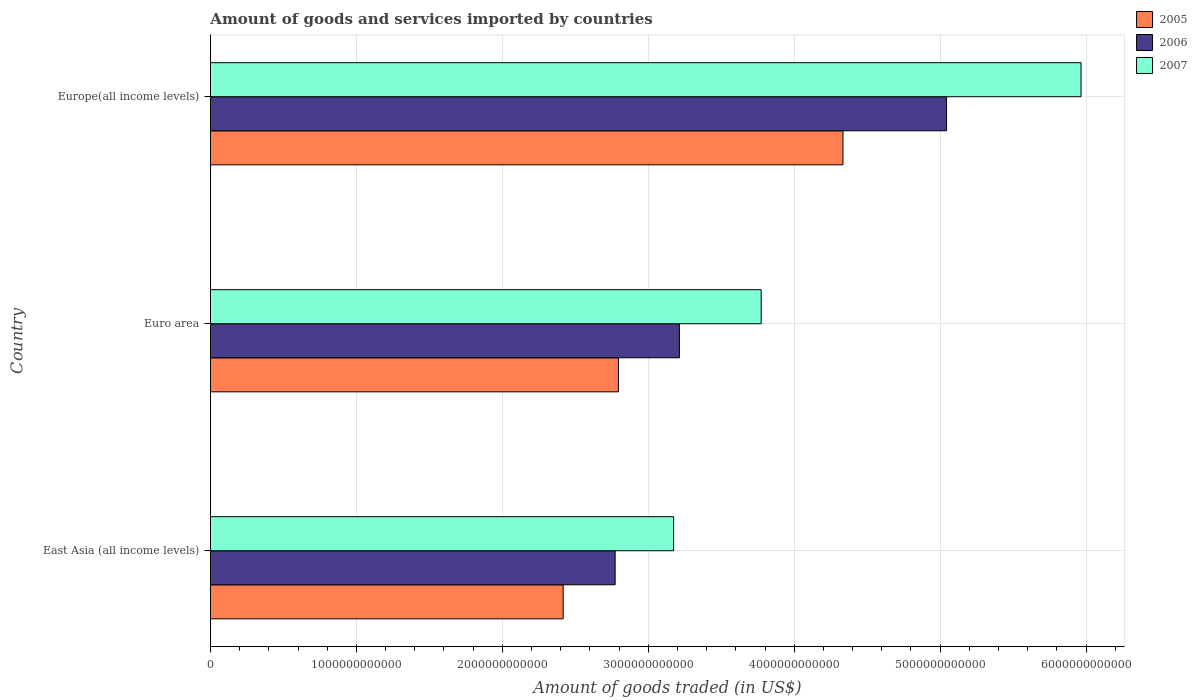How many groups of bars are there?
Make the answer very short. 3. Are the number of bars per tick equal to the number of legend labels?
Keep it short and to the point. Yes. Are the number of bars on each tick of the Y-axis equal?
Make the answer very short. Yes. How many bars are there on the 2nd tick from the top?
Provide a succinct answer. 3. What is the total amount of goods and services imported in 2006 in Euro area?
Ensure brevity in your answer.  3.21e+12. Across all countries, what is the maximum total amount of goods and services imported in 2006?
Give a very brief answer. 5.04e+12. Across all countries, what is the minimum total amount of goods and services imported in 2005?
Give a very brief answer. 2.42e+12. In which country was the total amount of goods and services imported in 2005 maximum?
Provide a succinct answer. Europe(all income levels). In which country was the total amount of goods and services imported in 2005 minimum?
Provide a short and direct response. East Asia (all income levels). What is the total total amount of goods and services imported in 2007 in the graph?
Ensure brevity in your answer.  1.29e+13. What is the difference between the total amount of goods and services imported in 2006 in East Asia (all income levels) and that in Euro area?
Offer a terse response. -4.40e+11. What is the difference between the total amount of goods and services imported in 2006 in Euro area and the total amount of goods and services imported in 2007 in East Asia (all income levels)?
Give a very brief answer. 3.96e+1. What is the average total amount of goods and services imported in 2005 per country?
Make the answer very short. 3.18e+12. What is the difference between the total amount of goods and services imported in 2005 and total amount of goods and services imported in 2007 in Euro area?
Your answer should be very brief. -9.78e+11. What is the ratio of the total amount of goods and services imported in 2007 in East Asia (all income levels) to that in Europe(all income levels)?
Your answer should be very brief. 0.53. Is the total amount of goods and services imported in 2007 in Euro area less than that in Europe(all income levels)?
Offer a terse response. Yes. What is the difference between the highest and the second highest total amount of goods and services imported in 2005?
Give a very brief answer. 1.54e+12. What is the difference between the highest and the lowest total amount of goods and services imported in 2007?
Provide a succinct answer. 2.79e+12. Is the sum of the total amount of goods and services imported in 2005 in East Asia (all income levels) and Euro area greater than the maximum total amount of goods and services imported in 2006 across all countries?
Offer a terse response. Yes. What does the 2nd bar from the top in East Asia (all income levels) represents?
Make the answer very short. 2006. What does the 1st bar from the bottom in Europe(all income levels) represents?
Your answer should be very brief. 2005. Is it the case that in every country, the sum of the total amount of goods and services imported in 2006 and total amount of goods and services imported in 2007 is greater than the total amount of goods and services imported in 2005?
Ensure brevity in your answer.  Yes. How many bars are there?
Offer a very short reply. 9. Are all the bars in the graph horizontal?
Make the answer very short. Yes. How many countries are there in the graph?
Ensure brevity in your answer.  3. What is the difference between two consecutive major ticks on the X-axis?
Make the answer very short. 1.00e+12. Where does the legend appear in the graph?
Your answer should be compact. Top right. What is the title of the graph?
Ensure brevity in your answer.  Amount of goods and services imported by countries. Does "1974" appear as one of the legend labels in the graph?
Provide a succinct answer. No. What is the label or title of the X-axis?
Your answer should be very brief. Amount of goods traded (in US$). What is the Amount of goods traded (in US$) of 2005 in East Asia (all income levels)?
Your response must be concise. 2.42e+12. What is the Amount of goods traded (in US$) of 2006 in East Asia (all income levels)?
Your response must be concise. 2.77e+12. What is the Amount of goods traded (in US$) in 2007 in East Asia (all income levels)?
Make the answer very short. 3.17e+12. What is the Amount of goods traded (in US$) in 2005 in Euro area?
Provide a short and direct response. 2.80e+12. What is the Amount of goods traded (in US$) of 2006 in Euro area?
Provide a short and direct response. 3.21e+12. What is the Amount of goods traded (in US$) in 2007 in Euro area?
Give a very brief answer. 3.77e+12. What is the Amount of goods traded (in US$) of 2005 in Europe(all income levels)?
Keep it short and to the point. 4.33e+12. What is the Amount of goods traded (in US$) in 2006 in Europe(all income levels)?
Ensure brevity in your answer.  5.04e+12. What is the Amount of goods traded (in US$) of 2007 in Europe(all income levels)?
Keep it short and to the point. 5.97e+12. Across all countries, what is the maximum Amount of goods traded (in US$) of 2005?
Offer a very short reply. 4.33e+12. Across all countries, what is the maximum Amount of goods traded (in US$) in 2006?
Offer a terse response. 5.04e+12. Across all countries, what is the maximum Amount of goods traded (in US$) in 2007?
Your answer should be compact. 5.97e+12. Across all countries, what is the minimum Amount of goods traded (in US$) of 2005?
Offer a terse response. 2.42e+12. Across all countries, what is the minimum Amount of goods traded (in US$) of 2006?
Your answer should be very brief. 2.77e+12. Across all countries, what is the minimum Amount of goods traded (in US$) in 2007?
Your response must be concise. 3.17e+12. What is the total Amount of goods traded (in US$) in 2005 in the graph?
Make the answer very short. 9.55e+12. What is the total Amount of goods traded (in US$) in 2006 in the graph?
Your answer should be very brief. 1.10e+13. What is the total Amount of goods traded (in US$) in 2007 in the graph?
Keep it short and to the point. 1.29e+13. What is the difference between the Amount of goods traded (in US$) in 2005 in East Asia (all income levels) and that in Euro area?
Offer a terse response. -3.79e+11. What is the difference between the Amount of goods traded (in US$) in 2006 in East Asia (all income levels) and that in Euro area?
Keep it short and to the point. -4.40e+11. What is the difference between the Amount of goods traded (in US$) of 2007 in East Asia (all income levels) and that in Euro area?
Your answer should be compact. -6.00e+11. What is the difference between the Amount of goods traded (in US$) of 2005 in East Asia (all income levels) and that in Europe(all income levels)?
Offer a very short reply. -1.92e+12. What is the difference between the Amount of goods traded (in US$) of 2006 in East Asia (all income levels) and that in Europe(all income levels)?
Keep it short and to the point. -2.27e+12. What is the difference between the Amount of goods traded (in US$) of 2007 in East Asia (all income levels) and that in Europe(all income levels)?
Ensure brevity in your answer.  -2.79e+12. What is the difference between the Amount of goods traded (in US$) in 2005 in Euro area and that in Europe(all income levels)?
Keep it short and to the point. -1.54e+12. What is the difference between the Amount of goods traded (in US$) of 2006 in Euro area and that in Europe(all income levels)?
Your answer should be compact. -1.83e+12. What is the difference between the Amount of goods traded (in US$) in 2007 in Euro area and that in Europe(all income levels)?
Your answer should be very brief. -2.19e+12. What is the difference between the Amount of goods traded (in US$) of 2005 in East Asia (all income levels) and the Amount of goods traded (in US$) of 2006 in Euro area?
Keep it short and to the point. -7.96e+11. What is the difference between the Amount of goods traded (in US$) in 2005 in East Asia (all income levels) and the Amount of goods traded (in US$) in 2007 in Euro area?
Ensure brevity in your answer.  -1.36e+12. What is the difference between the Amount of goods traded (in US$) of 2006 in East Asia (all income levels) and the Amount of goods traded (in US$) of 2007 in Euro area?
Offer a very short reply. -1.00e+12. What is the difference between the Amount of goods traded (in US$) in 2005 in East Asia (all income levels) and the Amount of goods traded (in US$) in 2006 in Europe(all income levels)?
Keep it short and to the point. -2.63e+12. What is the difference between the Amount of goods traded (in US$) of 2005 in East Asia (all income levels) and the Amount of goods traded (in US$) of 2007 in Europe(all income levels)?
Give a very brief answer. -3.55e+12. What is the difference between the Amount of goods traded (in US$) in 2006 in East Asia (all income levels) and the Amount of goods traded (in US$) in 2007 in Europe(all income levels)?
Provide a short and direct response. -3.19e+12. What is the difference between the Amount of goods traded (in US$) in 2005 in Euro area and the Amount of goods traded (in US$) in 2006 in Europe(all income levels)?
Offer a terse response. -2.25e+12. What is the difference between the Amount of goods traded (in US$) of 2005 in Euro area and the Amount of goods traded (in US$) of 2007 in Europe(all income levels)?
Provide a short and direct response. -3.17e+12. What is the difference between the Amount of goods traded (in US$) of 2006 in Euro area and the Amount of goods traded (in US$) of 2007 in Europe(all income levels)?
Provide a succinct answer. -2.75e+12. What is the average Amount of goods traded (in US$) in 2005 per country?
Your answer should be very brief. 3.18e+12. What is the average Amount of goods traded (in US$) in 2006 per country?
Ensure brevity in your answer.  3.68e+12. What is the average Amount of goods traded (in US$) of 2007 per country?
Offer a terse response. 4.30e+12. What is the difference between the Amount of goods traded (in US$) in 2005 and Amount of goods traded (in US$) in 2006 in East Asia (all income levels)?
Provide a short and direct response. -3.56e+11. What is the difference between the Amount of goods traded (in US$) in 2005 and Amount of goods traded (in US$) in 2007 in East Asia (all income levels)?
Give a very brief answer. -7.57e+11. What is the difference between the Amount of goods traded (in US$) in 2006 and Amount of goods traded (in US$) in 2007 in East Asia (all income levels)?
Offer a terse response. -4.01e+11. What is the difference between the Amount of goods traded (in US$) of 2005 and Amount of goods traded (in US$) of 2006 in Euro area?
Offer a very short reply. -4.18e+11. What is the difference between the Amount of goods traded (in US$) in 2005 and Amount of goods traded (in US$) in 2007 in Euro area?
Ensure brevity in your answer.  -9.78e+11. What is the difference between the Amount of goods traded (in US$) of 2006 and Amount of goods traded (in US$) of 2007 in Euro area?
Provide a succinct answer. -5.60e+11. What is the difference between the Amount of goods traded (in US$) in 2005 and Amount of goods traded (in US$) in 2006 in Europe(all income levels)?
Keep it short and to the point. -7.10e+11. What is the difference between the Amount of goods traded (in US$) in 2005 and Amount of goods traded (in US$) in 2007 in Europe(all income levels)?
Your answer should be compact. -1.63e+12. What is the difference between the Amount of goods traded (in US$) of 2006 and Amount of goods traded (in US$) of 2007 in Europe(all income levels)?
Ensure brevity in your answer.  -9.22e+11. What is the ratio of the Amount of goods traded (in US$) of 2005 in East Asia (all income levels) to that in Euro area?
Offer a very short reply. 0.86. What is the ratio of the Amount of goods traded (in US$) of 2006 in East Asia (all income levels) to that in Euro area?
Your answer should be compact. 0.86. What is the ratio of the Amount of goods traded (in US$) in 2007 in East Asia (all income levels) to that in Euro area?
Give a very brief answer. 0.84. What is the ratio of the Amount of goods traded (in US$) in 2005 in East Asia (all income levels) to that in Europe(all income levels)?
Offer a terse response. 0.56. What is the ratio of the Amount of goods traded (in US$) of 2006 in East Asia (all income levels) to that in Europe(all income levels)?
Provide a short and direct response. 0.55. What is the ratio of the Amount of goods traded (in US$) of 2007 in East Asia (all income levels) to that in Europe(all income levels)?
Give a very brief answer. 0.53. What is the ratio of the Amount of goods traded (in US$) in 2005 in Euro area to that in Europe(all income levels)?
Provide a succinct answer. 0.65. What is the ratio of the Amount of goods traded (in US$) in 2006 in Euro area to that in Europe(all income levels)?
Offer a terse response. 0.64. What is the ratio of the Amount of goods traded (in US$) in 2007 in Euro area to that in Europe(all income levels)?
Your answer should be very brief. 0.63. What is the difference between the highest and the second highest Amount of goods traded (in US$) of 2005?
Provide a succinct answer. 1.54e+12. What is the difference between the highest and the second highest Amount of goods traded (in US$) in 2006?
Provide a short and direct response. 1.83e+12. What is the difference between the highest and the second highest Amount of goods traded (in US$) in 2007?
Your answer should be compact. 2.19e+12. What is the difference between the highest and the lowest Amount of goods traded (in US$) in 2005?
Provide a succinct answer. 1.92e+12. What is the difference between the highest and the lowest Amount of goods traded (in US$) of 2006?
Your response must be concise. 2.27e+12. What is the difference between the highest and the lowest Amount of goods traded (in US$) in 2007?
Offer a terse response. 2.79e+12. 